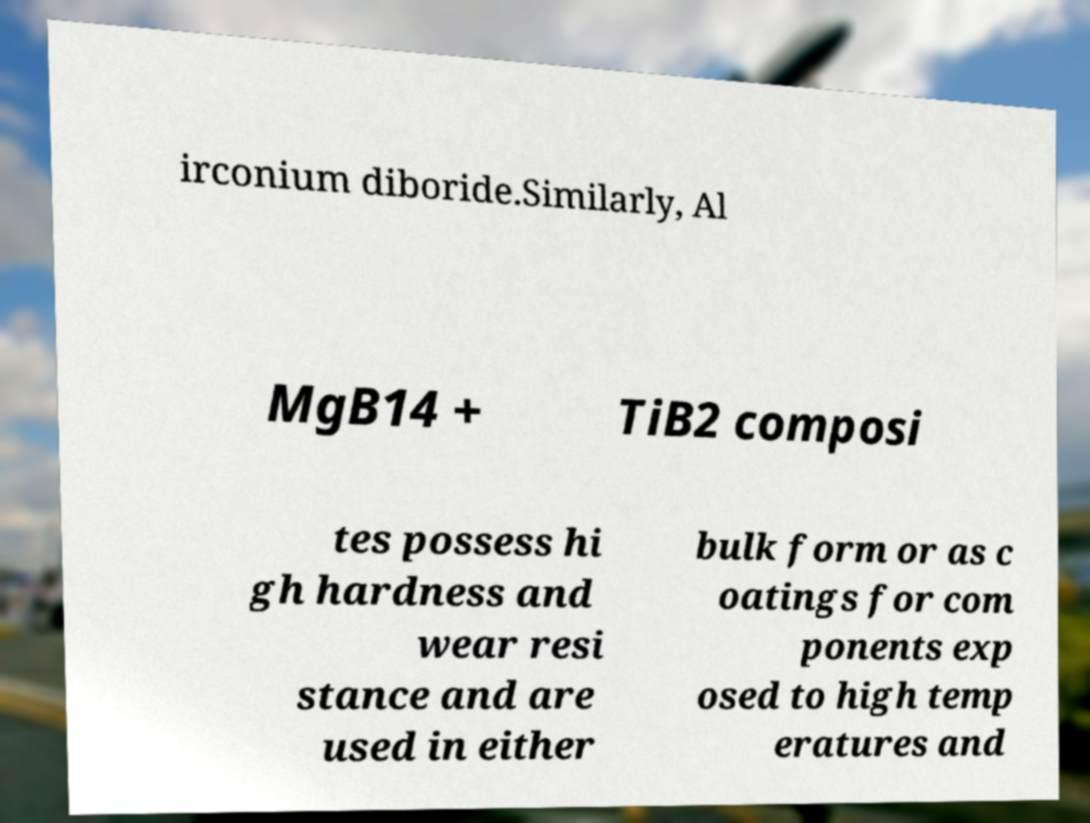What messages or text are displayed in this image? I need them in a readable, typed format. irconium diboride.Similarly, Al MgB14 + TiB2 composi tes possess hi gh hardness and wear resi stance and are used in either bulk form or as c oatings for com ponents exp osed to high temp eratures and 